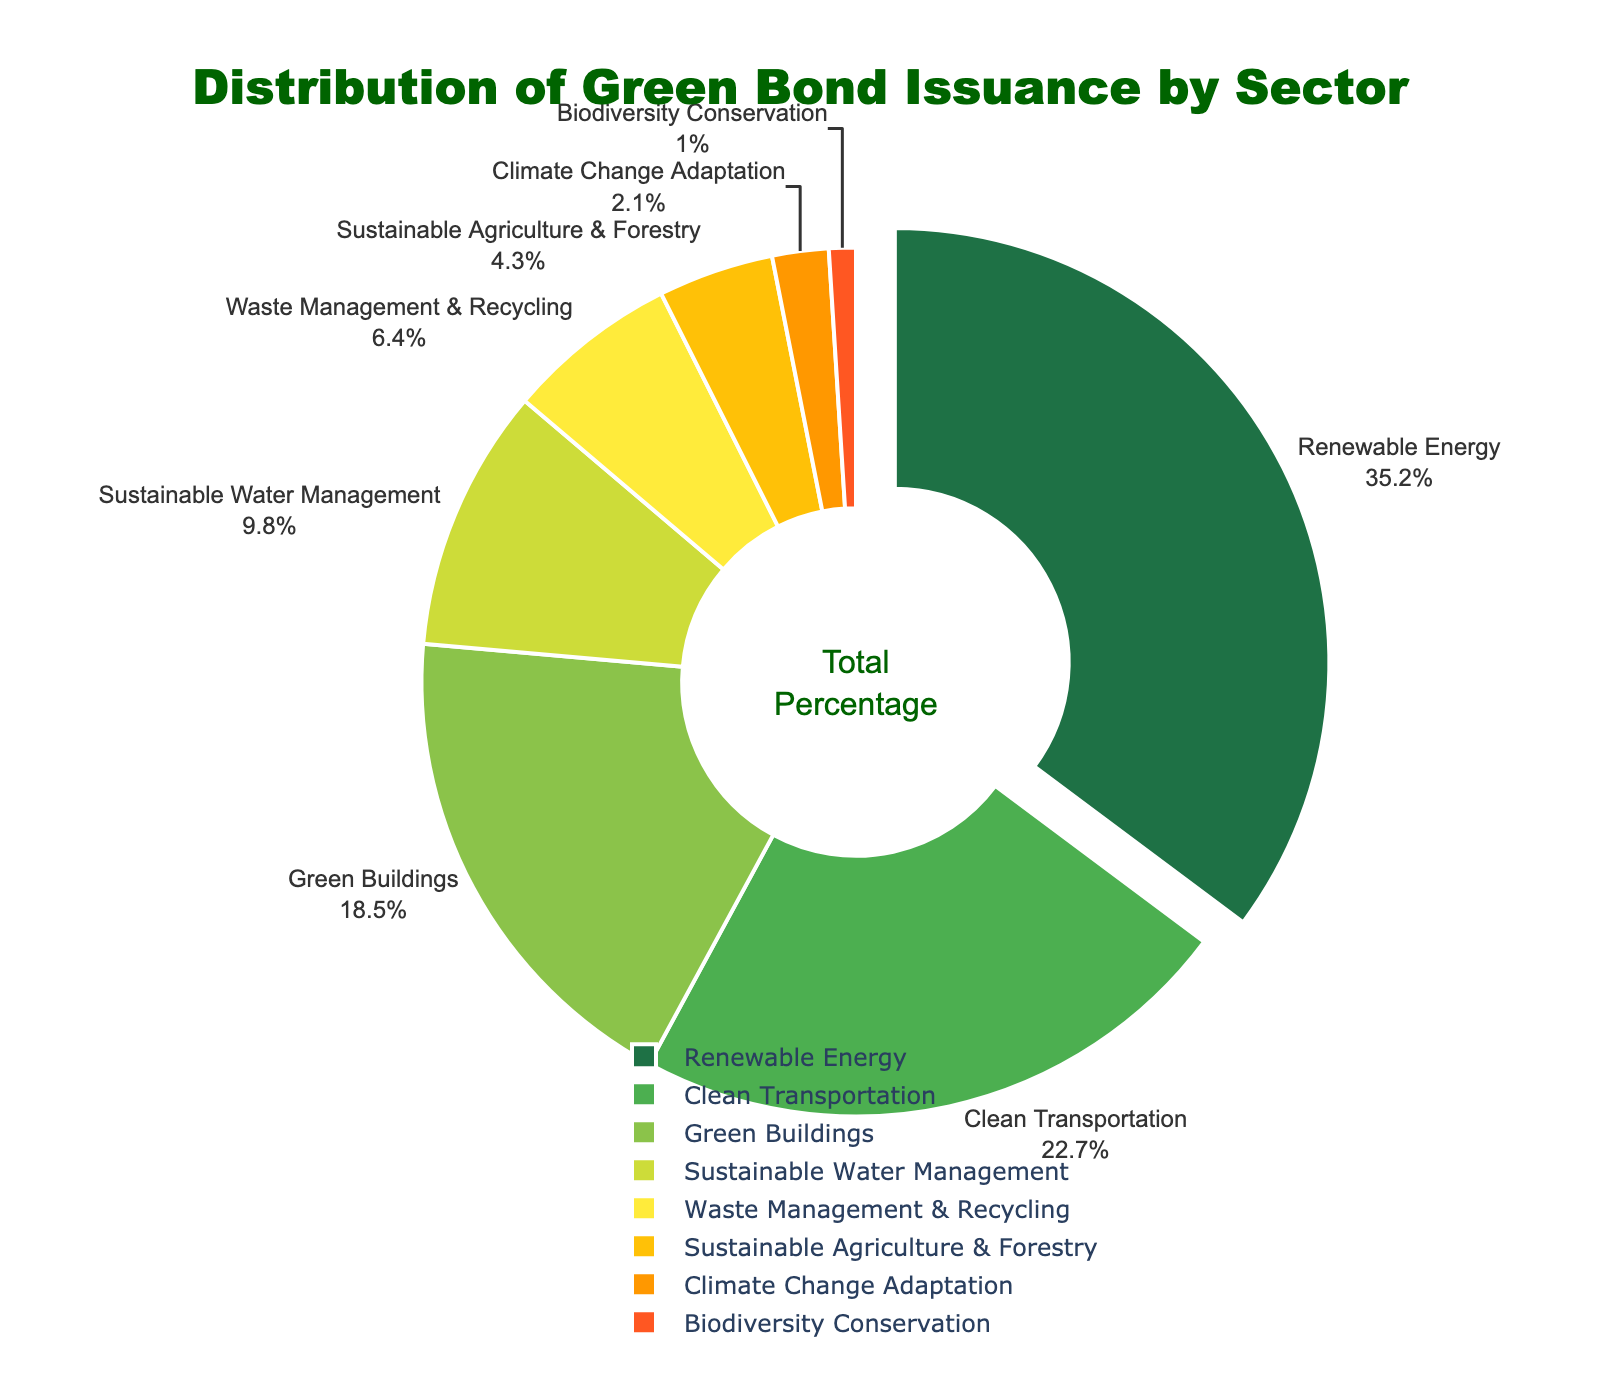What sector has the highest percentage of green bond issuance? The sector with the highest percentage is Renewable Energy. Its percentage is clearly labeled as 35.2%, which is the largest value on the chart.
Answer: Renewable Energy What is the combined percentage of Clean Transportation and Green Buildings? To find the combined percentage, add the percentages of Clean Transportation (22.7%) and Green Buildings (18.5%). The sum of these values is 22.7 + 18.5 = 41.2.
Answer: 41.2 Which sector has a higher percentage: Sustainable Water Management or Waste Management & Recycling? Comparing the percentages, Sustainable Water Management has 9.8% while Waste Management & Recycling has 6.4%. 9.8% is greater than 6.4%.
Answer: Sustainable Water Management What is the total percentage of sectors with less than 10% green bond issuance each? The sectors with less than 10% are Sustainable Water Management (9.8%), Waste Management & Recycling (6.4%), Sustainable Agriculture & Forestry (4.3%), Climate Change Adaptation (2.1%), and Biodiversity Conservation (1.0%). Summing these percentages: 9.8 + 6.4 + 4.3 + 2.1 + 1.0 = 23.6.
Answer: 23.6 Which sectors are represented using shades of green in the pie chart? The sectors represented in shades of green are Renewable Energy, Clean Transportation, Green Buildings, and Sustainable Water Management, as visually evident from the green shades used in the pie chart.
Answer: Renewable Energy, Clean Transportation, Green Buildings, Sustainable Water Management What is the difference in percentage between Renewable Energy and Climate Change Adaptation? The percentage for Renewable Energy is 35.2% and for Climate Change Adaptation is 2.1%. The difference is 35.2 - 2.1 = 33.1.
Answer: 33.1 How much more is the percentage of Green Buildings compared to Sustainable Agriculture & Forestry? Green Buildings have 18.5% while Sustainable Agriculture & Forestry have 4.3%. The difference is 18.5 - 4.3 = 14.2.
Answer: 14.2 What's the percentage of sectors grouped into the top 4 by green bond issuance? The top 4 sectors by green bond issuance are Renewable Energy (35.2%), Clean Transportation (22.7%), Green Buildings (18.5%), and Sustainable Water Management (9.8%). The sum of these percentages is 35.2 + 22.7 + 18.5 + 9.8 = 86.2.
Answer: 86.2 What sector is positioned closest to the top of the pie chart, and what percentage does it represent? The sector closest to the top of the pie chart is Renewable Energy, and it represents 35.2%.
Answer: Renewable Energy, 35.2 